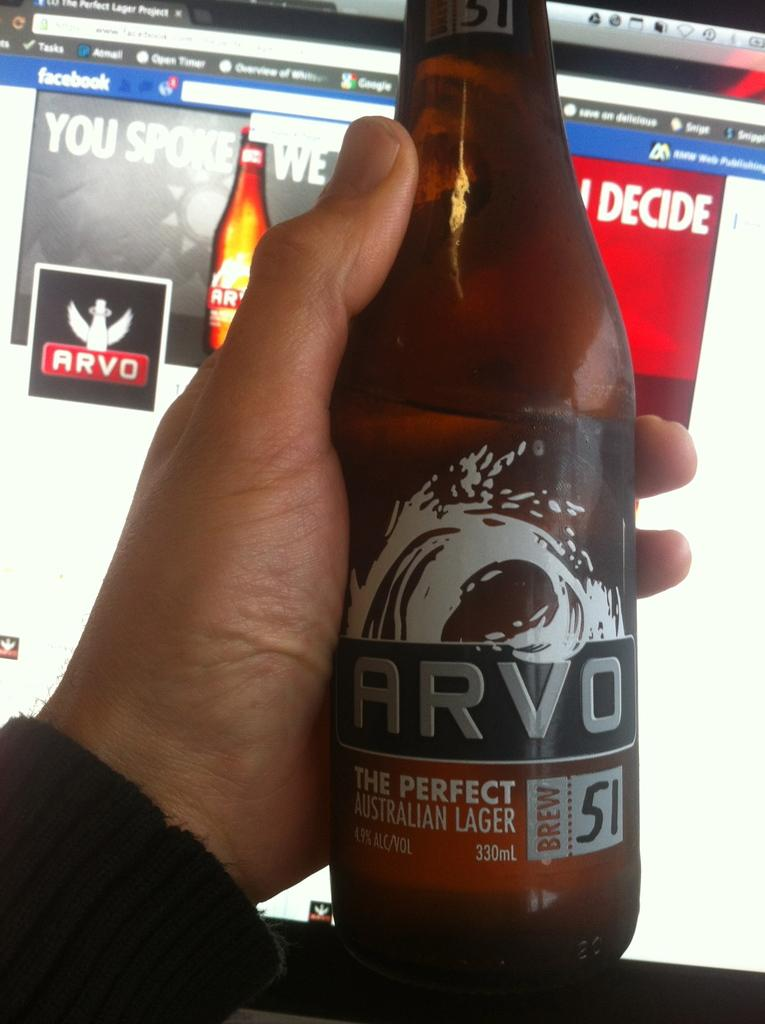<image>
Summarize the visual content of the image. a brown bottle of Arvo perfect Australian lager in front of a facebook screen 